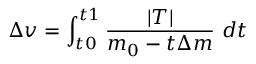<formula> <loc_0><loc_0><loc_500><loc_500>\Delta v = \int _ { t 0 } ^ { t 1 } { \frac { | T | } { { m _ { 0 } } - { t } \Delta { m } } } d t</formula> 